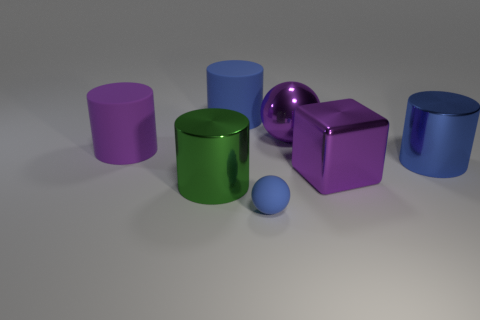There is a sphere that is the same color as the metallic block; what material is it?
Your answer should be very brief. Metal. How many big things have the same color as the large metal block?
Keep it short and to the point. 2. Do the green cylinder and the metal ball have the same size?
Your answer should be compact. Yes. There is a purple shiny thing that is in front of the big metallic thing on the right side of the metallic cube; how big is it?
Make the answer very short. Large. There is a cube; is its color the same as the metallic cylinder that is on the right side of the large shiny cube?
Keep it short and to the point. No. Are there any other cylinders that have the same size as the green metallic cylinder?
Provide a short and direct response. Yes. There is a purple object in front of the purple matte thing; what size is it?
Provide a short and direct response. Large. There is a ball behind the tiny rubber thing; is there a purple ball to the right of it?
Provide a succinct answer. No. How many other objects are there of the same shape as the green metal thing?
Give a very brief answer. 3. Is the shape of the big blue matte object the same as the purple matte thing?
Your response must be concise. Yes. 